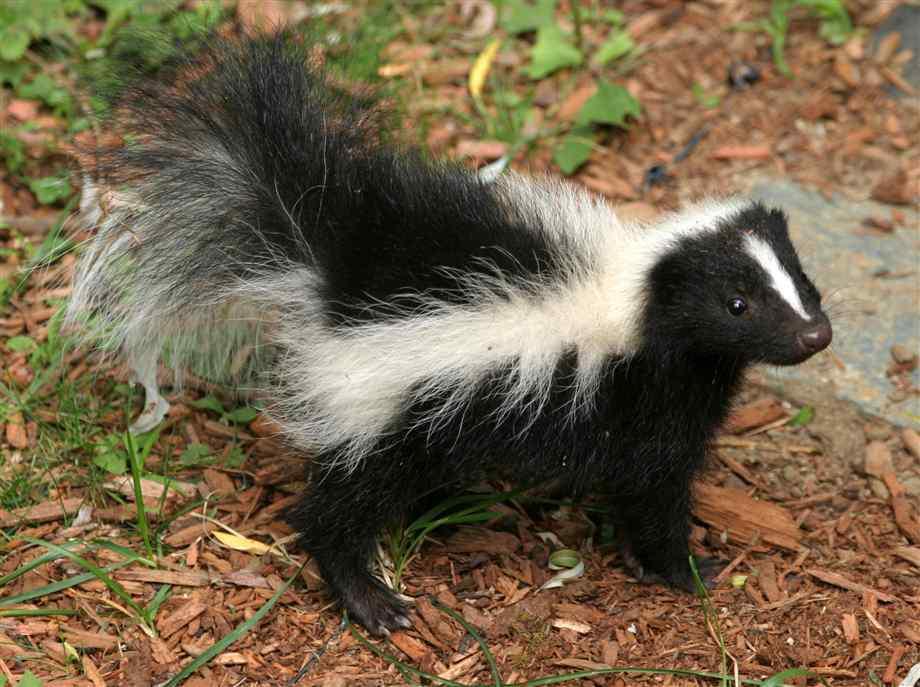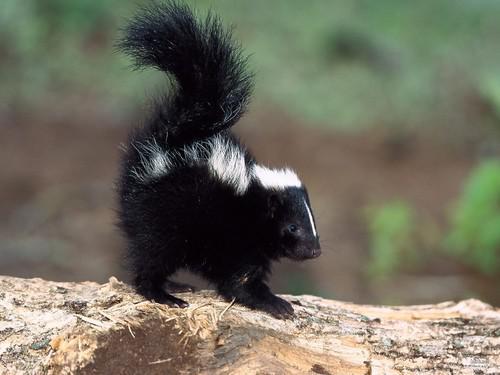The first image is the image on the left, the second image is the image on the right. Evaluate the accuracy of this statement regarding the images: "There are two skunks facing right.". Is it true? Answer yes or no. Yes. 